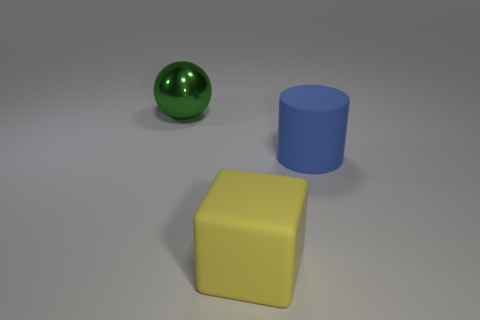What shape is the object that is made of the same material as the cylinder?
Offer a terse response. Cube. Is there anything else that has the same shape as the large yellow thing?
Your answer should be very brief. No. How many big rubber objects are to the left of the matte cylinder?
Make the answer very short. 1. Are there the same number of metal objects in front of the large yellow object and blocks?
Keep it short and to the point. No. Does the big yellow cube have the same material as the big blue object?
Provide a short and direct response. Yes. There is a thing that is on the right side of the big sphere and to the left of the big blue matte cylinder; what size is it?
Make the answer very short. Large. What number of yellow rubber cubes have the same size as the ball?
Your response must be concise. 1. There is a object that is behind the big matte thing behind the yellow thing; what size is it?
Your answer should be compact. Large. There is a thing that is to the right of the big green metallic sphere and behind the big yellow block; what is its color?
Offer a terse response. Blue. What color is the thing that is behind the cylinder?
Your answer should be very brief. Green. 